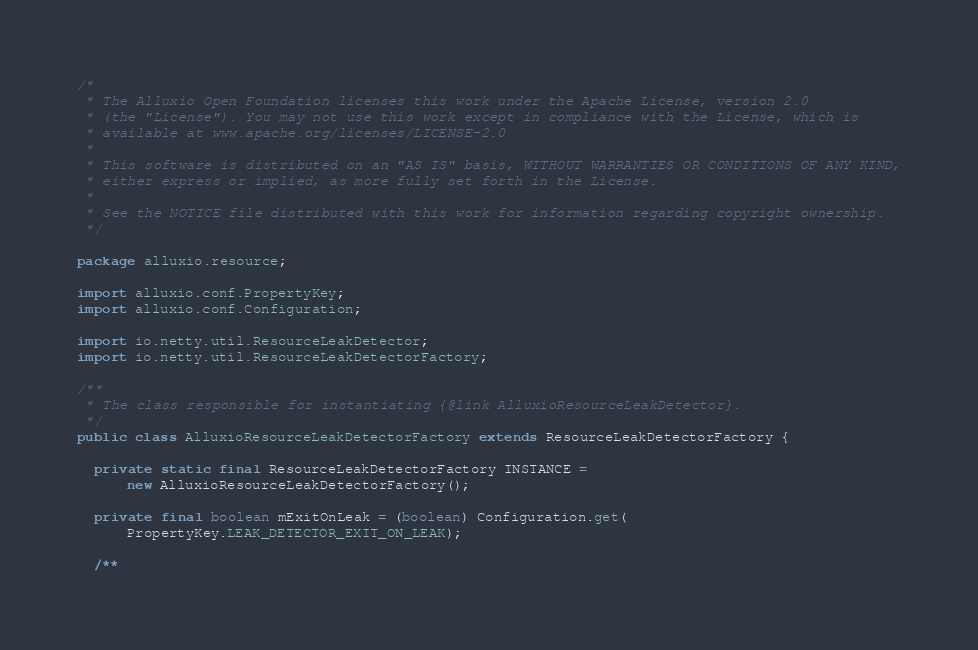Convert code to text. <code><loc_0><loc_0><loc_500><loc_500><_Java_>/*
 * The Alluxio Open Foundation licenses this work under the Apache License, version 2.0
 * (the "License"). You may not use this work except in compliance with the License, which is
 * available at www.apache.org/licenses/LICENSE-2.0
 *
 * This software is distributed on an "AS IS" basis, WITHOUT WARRANTIES OR CONDITIONS OF ANY KIND,
 * either express or implied, as more fully set forth in the License.
 *
 * See the NOTICE file distributed with this work for information regarding copyright ownership.
 */

package alluxio.resource;

import alluxio.conf.PropertyKey;
import alluxio.conf.Configuration;

import io.netty.util.ResourceLeakDetector;
import io.netty.util.ResourceLeakDetectorFactory;

/**
 * The class responsible for instantiating {@link AlluxioResourceLeakDetector}.
 */
public class AlluxioResourceLeakDetectorFactory extends ResourceLeakDetectorFactory {

  private static final ResourceLeakDetectorFactory INSTANCE =
      new AlluxioResourceLeakDetectorFactory();

  private final boolean mExitOnLeak = (boolean) Configuration.get(
      PropertyKey.LEAK_DETECTOR_EXIT_ON_LEAK);

  /**</code> 